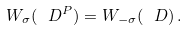Convert formula to latex. <formula><loc_0><loc_0><loc_500><loc_500>W _ { \sigma } ( \ D ^ { P } ) = W _ { - \sigma } ( \ D ) \, .</formula> 